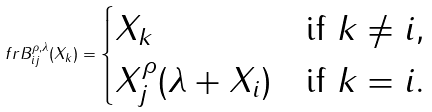Convert formula to latex. <formula><loc_0><loc_0><loc_500><loc_500>\ f r B ^ { \rho , \lambda } _ { i j } ( X _ { k } ) = \begin{cases} X _ { k } & \text {if } k \ne i , \\ X _ { j } ^ { \rho } ( \lambda + X _ { i } ) & \text {if } k = i . \end{cases}</formula> 